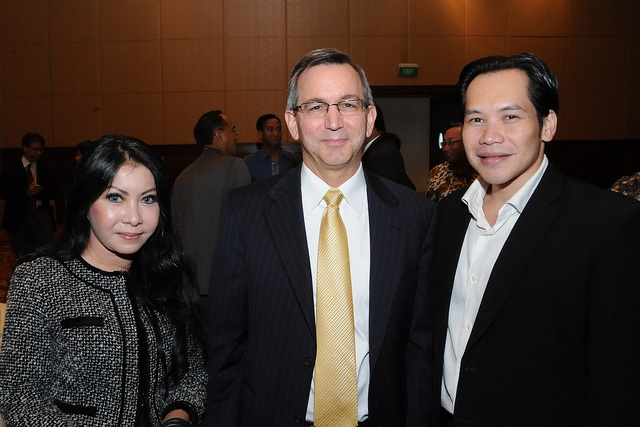Describe the objects in this image and their specific colors. I can see people in black, lightgray, and tan tones, people in black, lightgray, tan, and darkgray tones, people in black, gray, darkgray, and lightpink tones, people in black and maroon tones, and tie in black and tan tones in this image. 